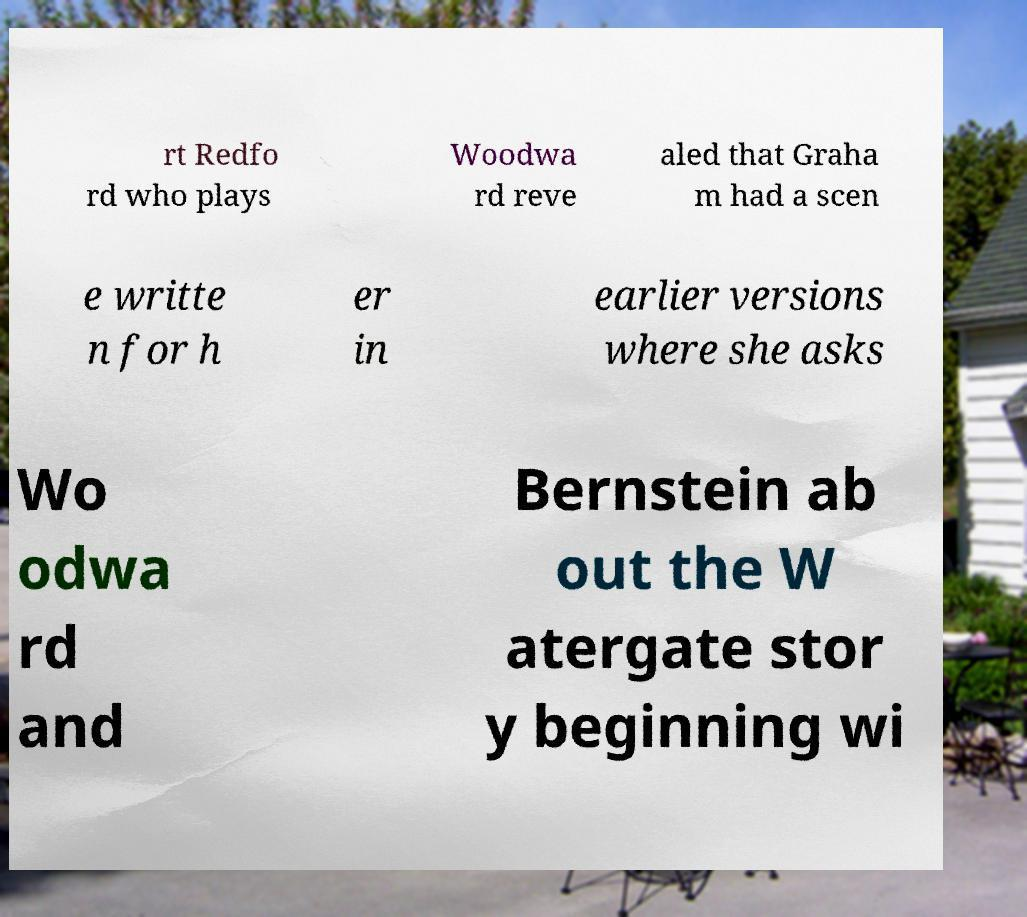I need the written content from this picture converted into text. Can you do that? rt Redfo rd who plays Woodwa rd reve aled that Graha m had a scen e writte n for h er in earlier versions where she asks Wo odwa rd and Bernstein ab out the W atergate stor y beginning wi 